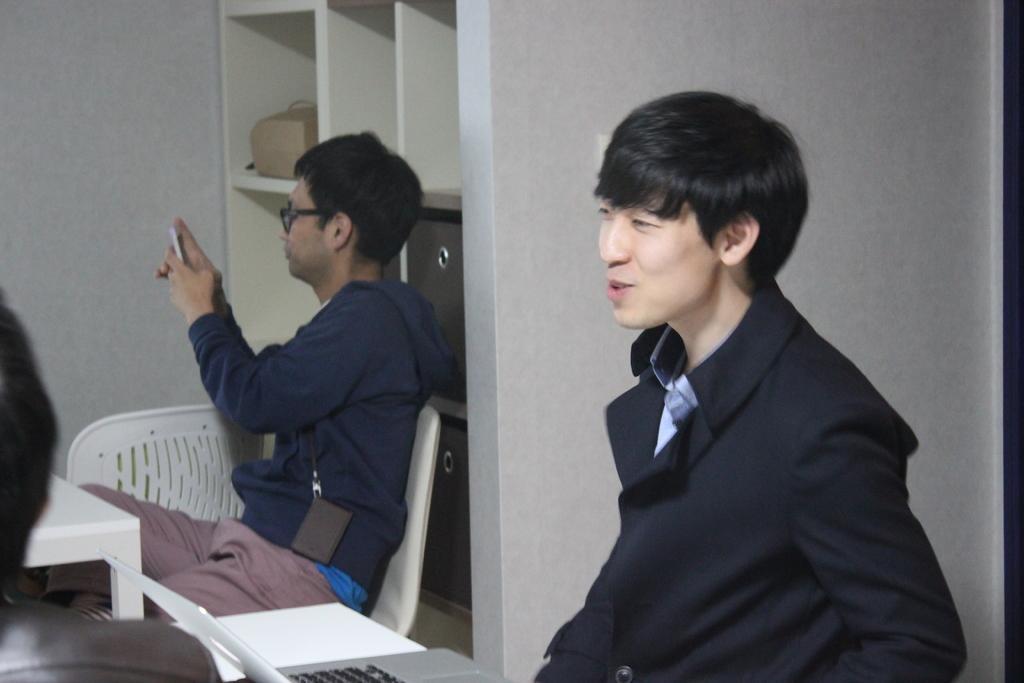Can you describe this image briefly? In this picture there is a man sitting and talking and there is a man sitting and holding the object. There is a man in the foreground and there is a laptop on the table. At the back there is a chair and table and there are objects in the shelf. 